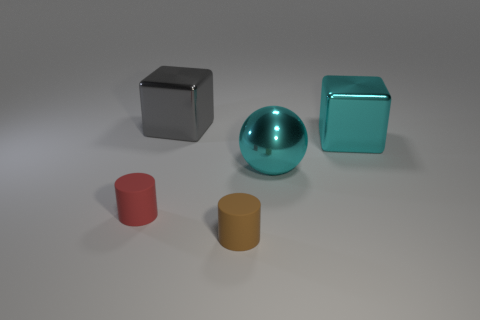Add 1 metallic blocks. How many objects exist? 6 Subtract all cylinders. How many objects are left? 3 Add 4 tiny purple rubber balls. How many tiny purple rubber balls exist? 4 Subtract 0 green balls. How many objects are left? 5 Subtract all cyan matte things. Subtract all small red objects. How many objects are left? 4 Add 3 small red matte things. How many small red matte things are left? 4 